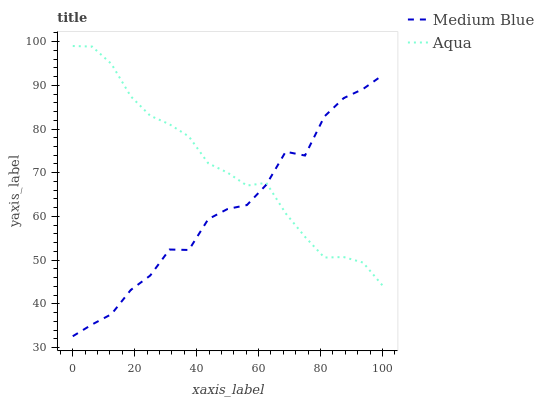Does Medium Blue have the minimum area under the curve?
Answer yes or no. Yes. Does Aqua have the maximum area under the curve?
Answer yes or no. Yes. Does Medium Blue have the maximum area under the curve?
Answer yes or no. No. Is Aqua the smoothest?
Answer yes or no. Yes. Is Medium Blue the roughest?
Answer yes or no. Yes. Is Medium Blue the smoothest?
Answer yes or no. No. Does Medium Blue have the highest value?
Answer yes or no. No. 